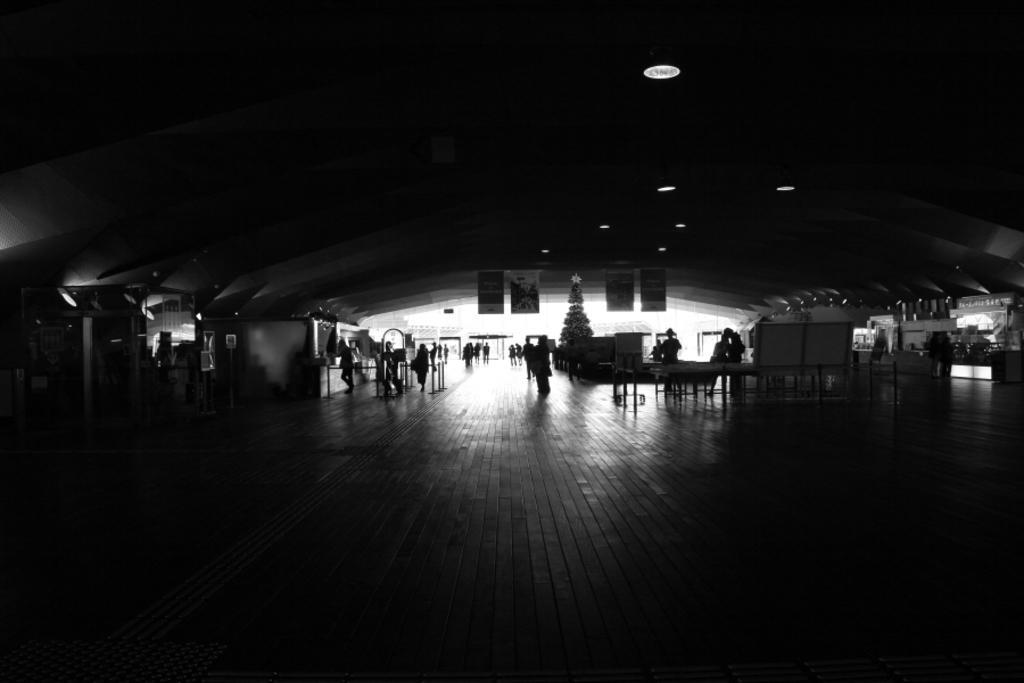Can you describe this image briefly? This picture is dark,at the top we can see lights and posters. In the background we can see people,tables and Christmas tree. 